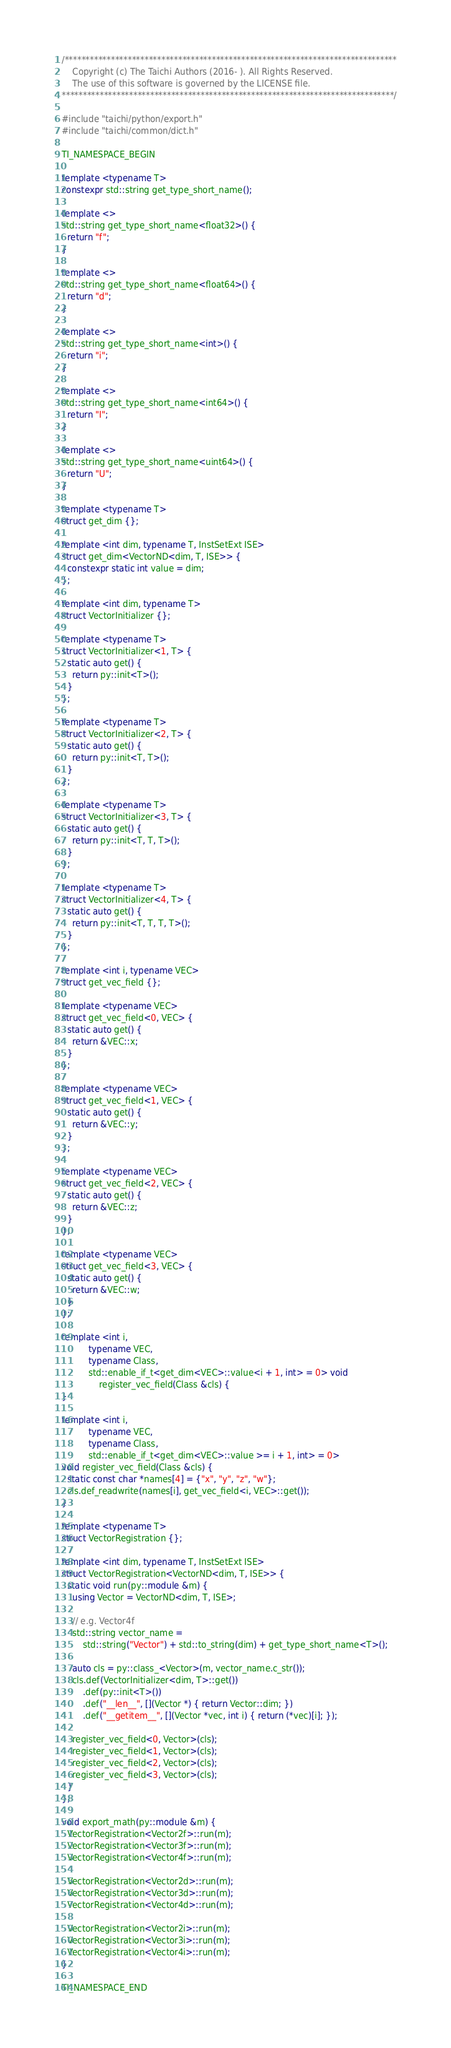<code> <loc_0><loc_0><loc_500><loc_500><_C++_>/*******************************************************************************
    Copyright (c) The Taichi Authors (2016- ). All Rights Reserved.
    The use of this software is governed by the LICENSE file.
*******************************************************************************/

#include "taichi/python/export.h"
#include "taichi/common/dict.h"

TI_NAMESPACE_BEGIN

template <typename T>
constexpr std::string get_type_short_name();

template <>
std::string get_type_short_name<float32>() {
  return "f";
}

template <>
std::string get_type_short_name<float64>() {
  return "d";
}

template <>
std::string get_type_short_name<int>() {
  return "i";
}

template <>
std::string get_type_short_name<int64>() {
  return "I";
}

template <>
std::string get_type_short_name<uint64>() {
  return "U";
}

template <typename T>
struct get_dim {};

template <int dim, typename T, InstSetExt ISE>
struct get_dim<VectorND<dim, T, ISE>> {
  constexpr static int value = dim;
};

template <int dim, typename T>
struct VectorInitializer {};

template <typename T>
struct VectorInitializer<1, T> {
  static auto get() {
    return py::init<T>();
  }
};

template <typename T>
struct VectorInitializer<2, T> {
  static auto get() {
    return py::init<T, T>();
  }
};

template <typename T>
struct VectorInitializer<3, T> {
  static auto get() {
    return py::init<T, T, T>();
  }
};

template <typename T>
struct VectorInitializer<4, T> {
  static auto get() {
    return py::init<T, T, T, T>();
  }
};

template <int i, typename VEC>
struct get_vec_field {};

template <typename VEC>
struct get_vec_field<0, VEC> {
  static auto get() {
    return &VEC::x;
  }
};

template <typename VEC>
struct get_vec_field<1, VEC> {
  static auto get() {
    return &VEC::y;
  }
};

template <typename VEC>
struct get_vec_field<2, VEC> {
  static auto get() {
    return &VEC::z;
  }
};

template <typename VEC>
struct get_vec_field<3, VEC> {
  static auto get() {
    return &VEC::w;
  }
};

template <int i,
          typename VEC,
          typename Class,
          std::enable_if_t<get_dim<VEC>::value<i + 1, int> = 0> void
              register_vec_field(Class &cls) {
}

template <int i,
          typename VEC,
          typename Class,
          std::enable_if_t<get_dim<VEC>::value >= i + 1, int> = 0>
void register_vec_field(Class &cls) {
  static const char *names[4] = {"x", "y", "z", "w"};
  cls.def_readwrite(names[i], get_vec_field<i, VEC>::get());
}

template <typename T>
struct VectorRegistration {};

template <int dim, typename T, InstSetExt ISE>
struct VectorRegistration<VectorND<dim, T, ISE>> {
  static void run(py::module &m) {
    using Vector = VectorND<dim, T, ISE>;

    // e.g. Vector4f
    std::string vector_name =
        std::string("Vector") + std::to_string(dim) + get_type_short_name<T>();

    auto cls = py::class_<Vector>(m, vector_name.c_str());
    cls.def(VectorInitializer<dim, T>::get())
        .def(py::init<T>())
        .def("__len__", [](Vector *) { return Vector::dim; })
        .def("__getitem__", [](Vector *vec, int i) { return (*vec)[i]; });

    register_vec_field<0, Vector>(cls);
    register_vec_field<1, Vector>(cls);
    register_vec_field<2, Vector>(cls);
    register_vec_field<3, Vector>(cls);
  }
};

void export_math(py::module &m) {
  VectorRegistration<Vector2f>::run(m);
  VectorRegistration<Vector3f>::run(m);
  VectorRegistration<Vector4f>::run(m);

  VectorRegistration<Vector2d>::run(m);
  VectorRegistration<Vector3d>::run(m);
  VectorRegistration<Vector4d>::run(m);

  VectorRegistration<Vector2i>::run(m);
  VectorRegistration<Vector3i>::run(m);
  VectorRegistration<Vector4i>::run(m);
}

TI_NAMESPACE_END
</code> 